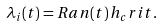<formula> <loc_0><loc_0><loc_500><loc_500>\lambda _ { i } ( t ) = R a n ( t ) \, h _ { c } r i t .</formula> 